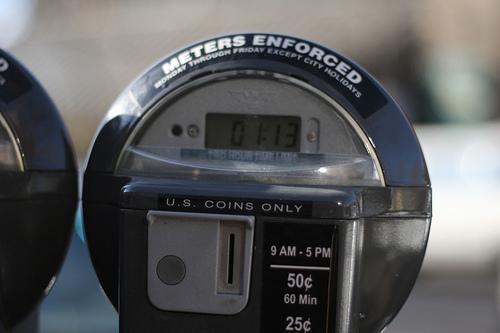How many parking meters are there?
Give a very brief answer. 2. How many giraffe are standing in the field?
Give a very brief answer. 0. 